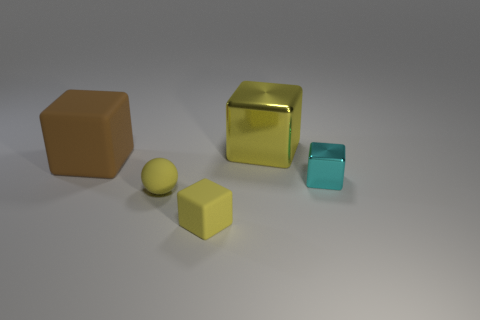What is the size of the rubber block that is the same color as the rubber sphere?
Provide a succinct answer. Small. How many other objects are there of the same size as the brown rubber cube?
Offer a very short reply. 1. There is a tiny yellow thing that is right of the yellow ball; what is it made of?
Offer a very short reply. Rubber. Do the small cyan metal object and the big yellow object have the same shape?
Offer a very short reply. Yes. How many other objects are there of the same shape as the tiny cyan metal object?
Your response must be concise. 3. There is a matte block in front of the big brown cube; what color is it?
Make the answer very short. Yellow. Is the cyan object the same size as the brown rubber thing?
Ensure brevity in your answer.  No. There is a small thing that is to the left of the small cube left of the small cyan object; what is its material?
Keep it short and to the point. Rubber. What number of tiny objects are the same color as the small matte sphere?
Offer a very short reply. 1. Is there any other thing that has the same material as the big yellow cube?
Keep it short and to the point. Yes. 